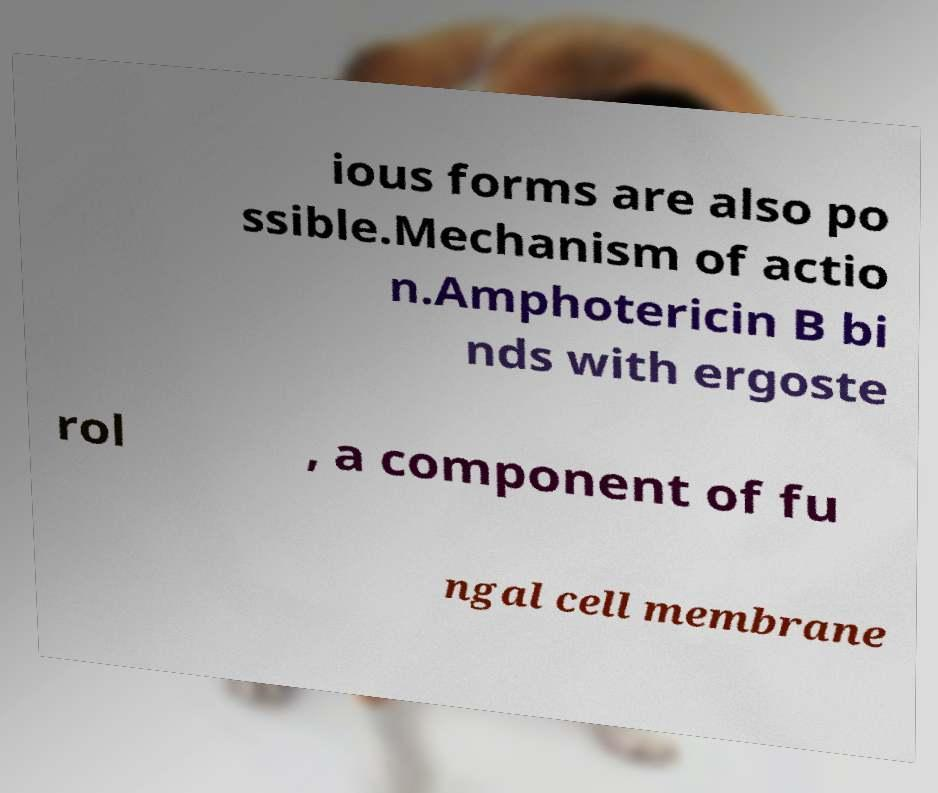Please identify and transcribe the text found in this image. ious forms are also po ssible.Mechanism of actio n.Amphotericin B bi nds with ergoste rol , a component of fu ngal cell membrane 